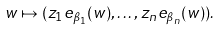<formula> <loc_0><loc_0><loc_500><loc_500>w \mapsto ( z _ { 1 } e _ { \beta _ { 1 } } ( w ) , \dots , z _ { n } e _ { \beta _ { n } } ( w ) ) .</formula> 